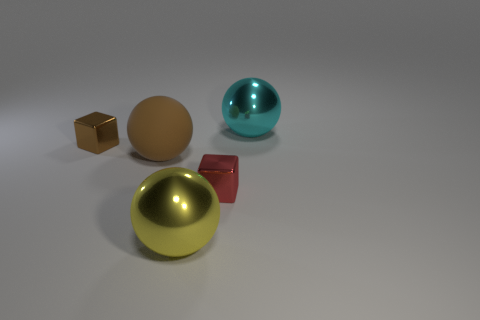What material is the large sphere that is right of the cube in front of the small shiny block that is to the left of the yellow metal object made of? metal 